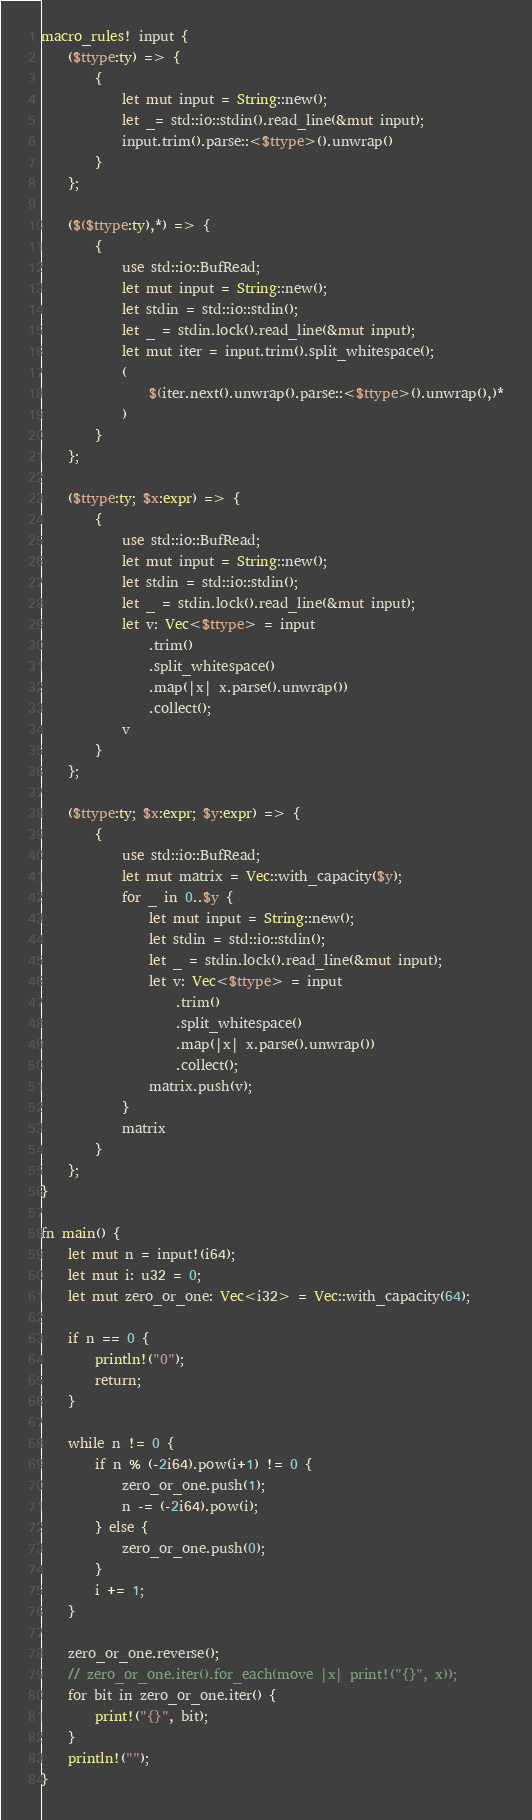<code> <loc_0><loc_0><loc_500><loc_500><_Rust_>macro_rules! input {
    ($ttype:ty) => {
        {
            let mut input = String::new();
            let _= std::io::stdin().read_line(&mut input);
            input.trim().parse::<$ttype>().unwrap()
        }
    };

    ($($ttype:ty),*) => {
        {
            use std::io::BufRead;
            let mut input = String::new();
            let stdin = std::io::stdin();
            let _ = stdin.lock().read_line(&mut input);
            let mut iter = input.trim().split_whitespace();
            (
                $(iter.next().unwrap().parse::<$ttype>().unwrap(),)*
            )
        }
    };

    ($ttype:ty; $x:expr) => {
        {
            use std::io::BufRead;
            let mut input = String::new();
            let stdin = std::io::stdin();
            let _ = stdin.lock().read_line(&mut input);
            let v: Vec<$ttype> = input
                .trim()
                .split_whitespace()
                .map(|x| x.parse().unwrap())
                .collect();
            v
        }
    };

    ($ttype:ty; $x:expr; $y:expr) => {
        {
            use std::io::BufRead;
            let mut matrix = Vec::with_capacity($y);
            for _ in 0..$y {
                let mut input = String::new();
                let stdin = std::io::stdin();
                let _ = stdin.lock().read_line(&mut input);
                let v: Vec<$ttype> = input
                    .trim()
                    .split_whitespace()
                    .map(|x| x.parse().unwrap())
                    .collect();
                matrix.push(v);
            }
            matrix
        }
    };
}

fn main() {
    let mut n = input!(i64);
    let mut i: u32 = 0;
    let mut zero_or_one: Vec<i32> = Vec::with_capacity(64);

    if n == 0 {
        println!("0");
        return;
    }

    while n != 0 {
        if n % (-2i64).pow(i+1) != 0 {
            zero_or_one.push(1);
            n -= (-2i64).pow(i);
        } else {
            zero_or_one.push(0);
        }
        i += 1;
    }

    zero_or_one.reverse();
    // zero_or_one.iter().for_each(move |x| print!("{}", x));
    for bit in zero_or_one.iter() {
        print!("{}", bit);
    }
    println!("");
}
</code> 